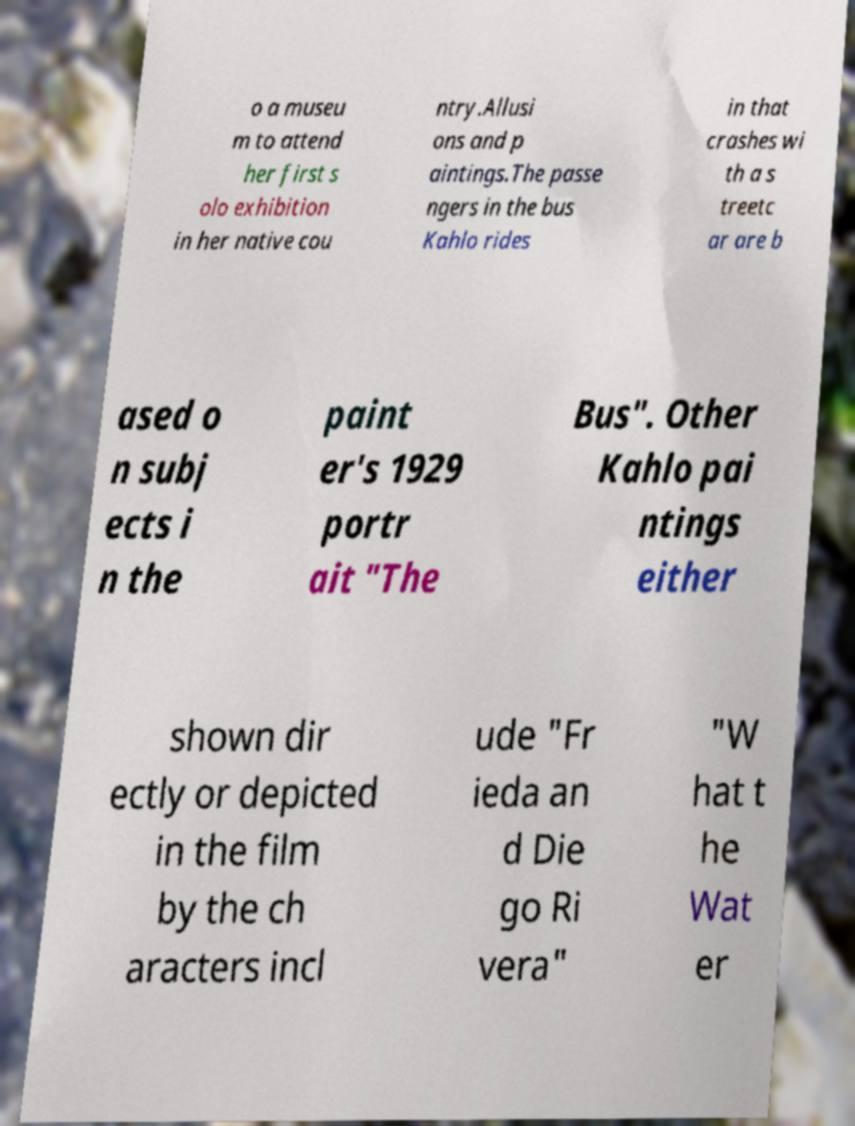Please read and relay the text visible in this image. What does it say? o a museu m to attend her first s olo exhibition in her native cou ntry.Allusi ons and p aintings.The passe ngers in the bus Kahlo rides in that crashes wi th a s treetc ar are b ased o n subj ects i n the paint er's 1929 portr ait "The Bus". Other Kahlo pai ntings either shown dir ectly or depicted in the film by the ch aracters incl ude "Fr ieda an d Die go Ri vera" "W hat t he Wat er 